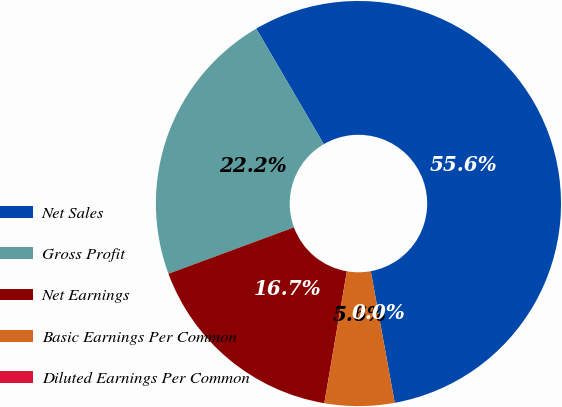Convert chart to OTSL. <chart><loc_0><loc_0><loc_500><loc_500><pie_chart><fcel>Net Sales<fcel>Gross Profit<fcel>Net Earnings<fcel>Basic Earnings Per Common<fcel>Diluted Earnings Per Common<nl><fcel>55.55%<fcel>22.22%<fcel>16.67%<fcel>5.56%<fcel>0.0%<nl></chart> 